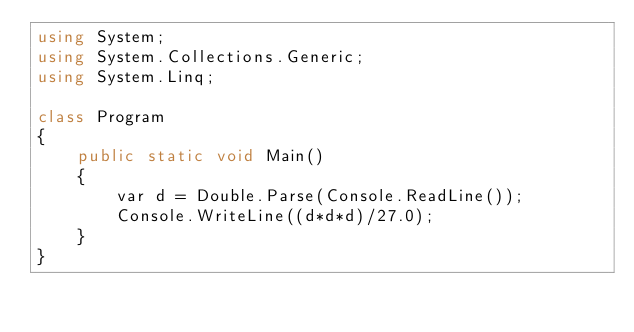<code> <loc_0><loc_0><loc_500><loc_500><_C#_>using System;
using System.Collections.Generic;
using System.Linq;

class Program
{
    public static void Main()
    {
        var d = Double.Parse(Console.ReadLine());
        Console.WriteLine((d*d*d)/27.0);
    }
}
</code> 